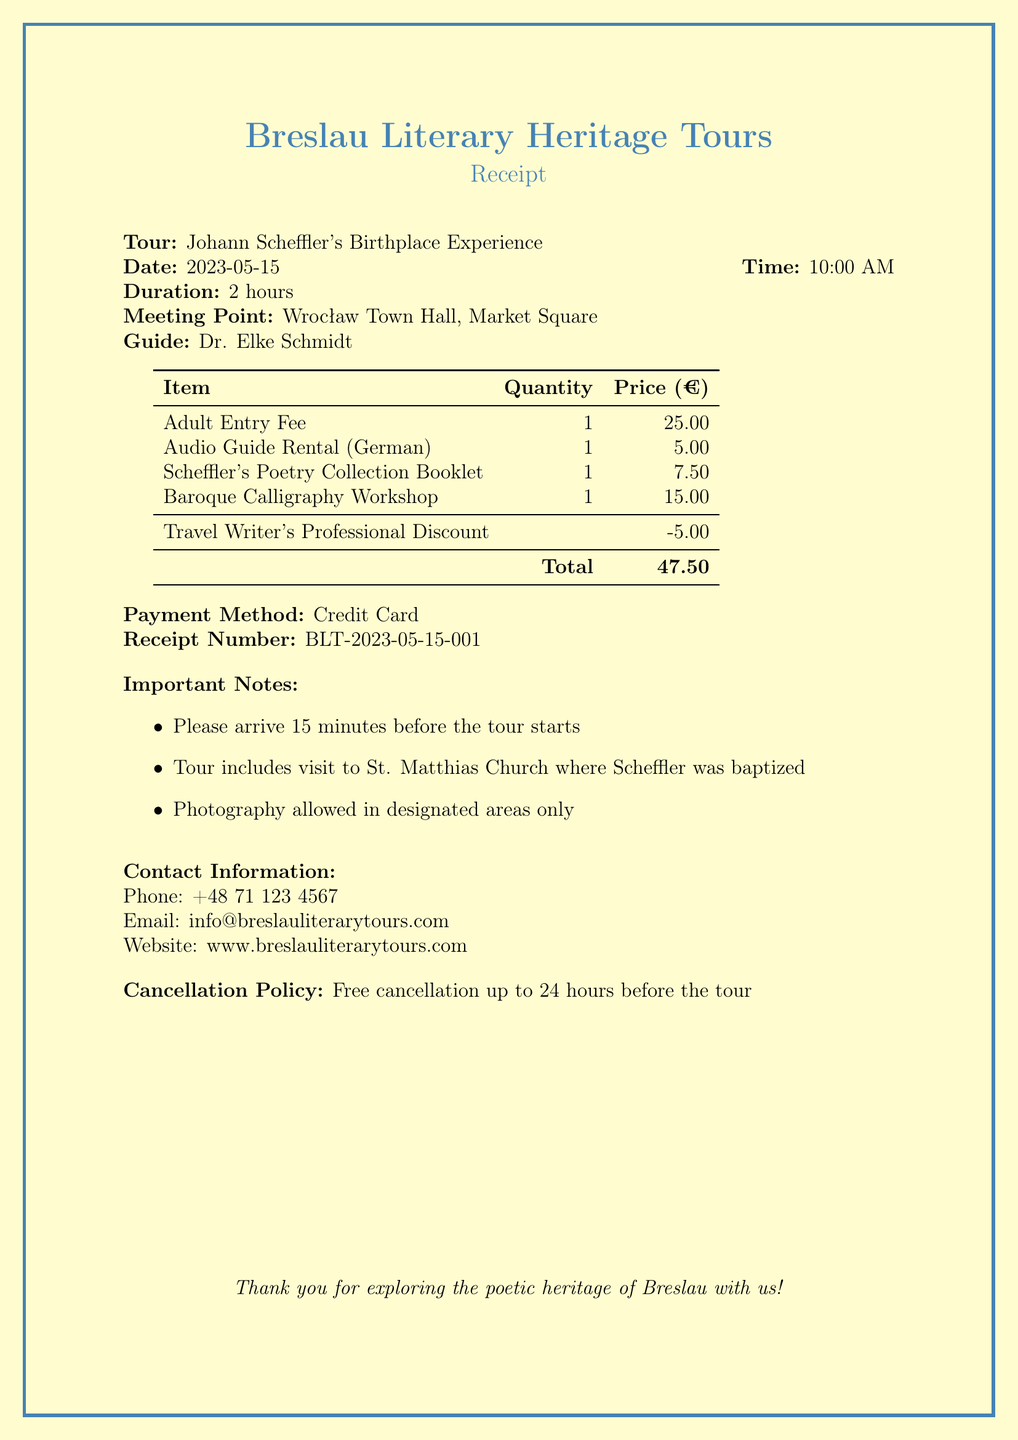What is the name of the tour operator? The tour operator is the organization providing the guided tour, mentioned at the top of the document.
Answer: Breslau Literary Heritage Tours What is the date of the tour? The date of the tour is specified in the document.
Answer: 2023-05-15 Who is the guide for the tour? The name of the guide is provided in the document under the tour details section.
Answer: Dr. Elke Schmidt How much is the adult entry fee? The price for the adult entry fee is listed in the items section of the receipt.
Answer: 25.00 What is the total amount charged? The total amount is calculated by summing the individual prices and then applying any discounts.
Answer: 47.50 What is one of the important notes mentioned? The document includes several important notes for participants; one of them needs to be referenced.
Answer: Please arrive 15 minutes before the tour starts What is the cancellation policy? The cancellation policy outlines the rules regarding tour cancellation and is mentioned in the document.
Answer: Free cancellation up to 24 hours before the tour How long is the tour? The duration of the tour is explicitly stated in the document.
Answer: 2 hours 